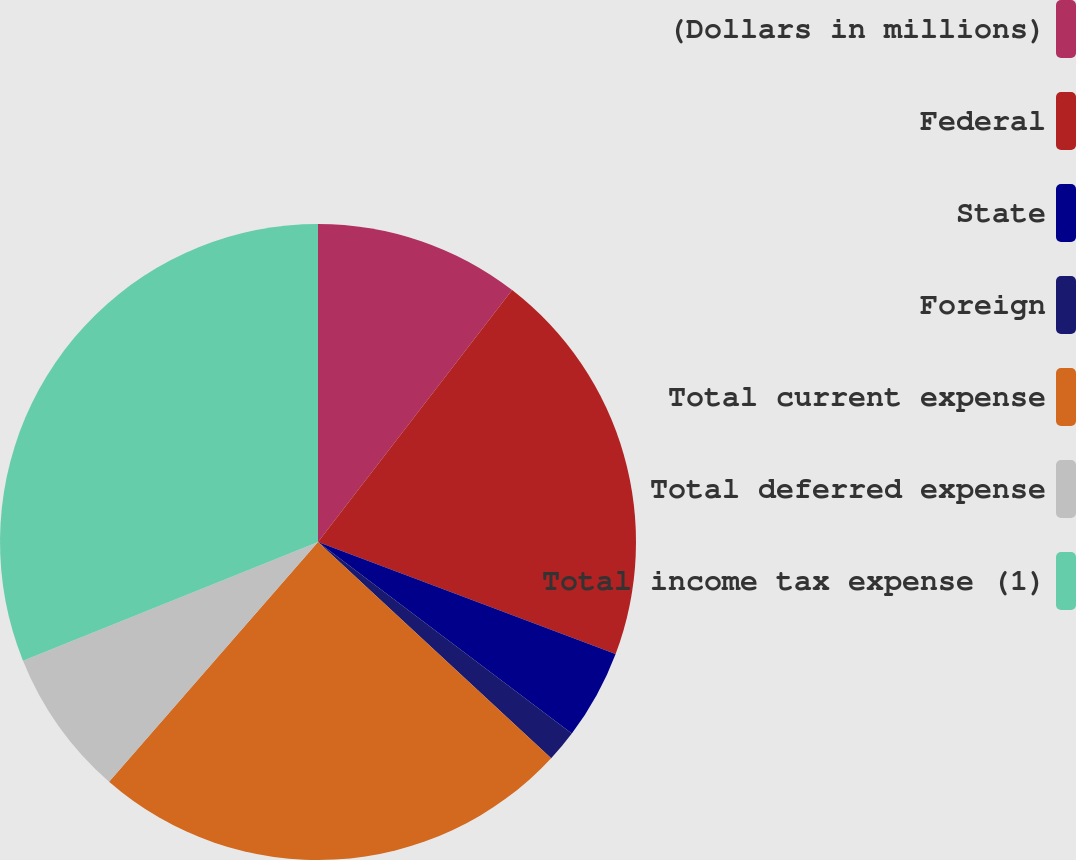Convert chart to OTSL. <chart><loc_0><loc_0><loc_500><loc_500><pie_chart><fcel>(Dollars in millions)<fcel>Federal<fcel>State<fcel>Foreign<fcel>Total current expense<fcel>Total deferred expense<fcel>Total income tax expense (1)<nl><fcel>10.45%<fcel>20.28%<fcel>4.56%<fcel>1.61%<fcel>24.51%<fcel>7.5%<fcel>31.09%<nl></chart> 